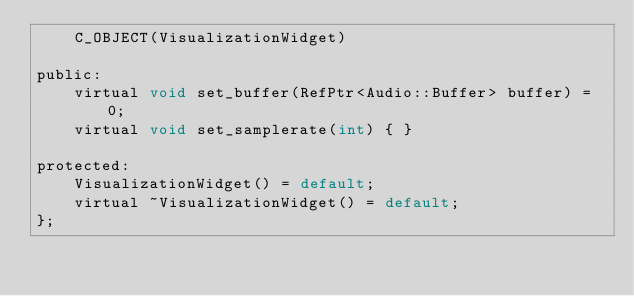<code> <loc_0><loc_0><loc_500><loc_500><_C_>    C_OBJECT(VisualizationWidget)

public:
    virtual void set_buffer(RefPtr<Audio::Buffer> buffer) = 0;
    virtual void set_samplerate(int) { }

protected:
    VisualizationWidget() = default;
    virtual ~VisualizationWidget() = default;
};
</code> 